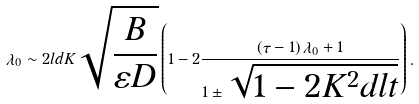Convert formula to latex. <formula><loc_0><loc_0><loc_500><loc_500>\lambda _ { 0 } \sim 2 l d K \sqrt { \frac { B } { \varepsilon D } } \left ( 1 - 2 \frac { \left ( \tau - 1 \right ) \lambda _ { 0 } + 1 } { 1 \pm \sqrt { 1 - 2 K ^ { 2 } d l t } } \right ) .</formula> 